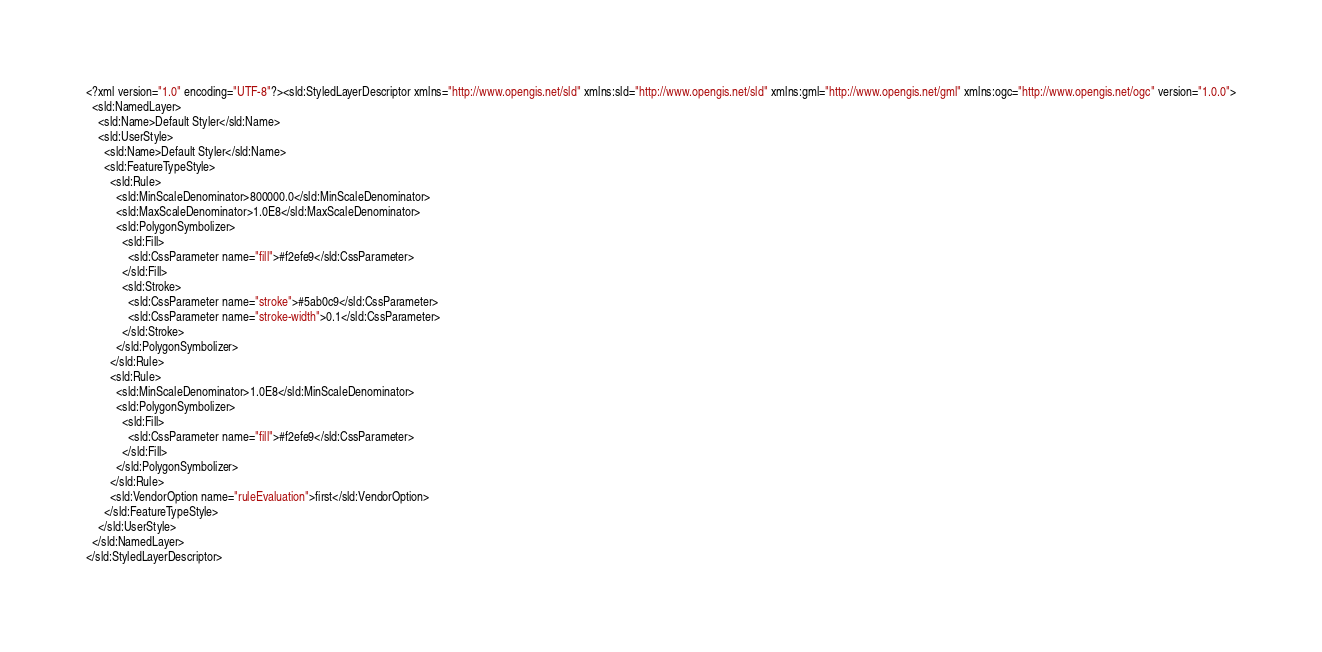<code> <loc_0><loc_0><loc_500><loc_500><_Scheme_><?xml version="1.0" encoding="UTF-8"?><sld:StyledLayerDescriptor xmlns="http://www.opengis.net/sld" xmlns:sld="http://www.opengis.net/sld" xmlns:gml="http://www.opengis.net/gml" xmlns:ogc="http://www.opengis.net/ogc" version="1.0.0">
  <sld:NamedLayer>
    <sld:Name>Default Styler</sld:Name>
    <sld:UserStyle>
      <sld:Name>Default Styler</sld:Name>
      <sld:FeatureTypeStyle>
        <sld:Rule>
          <sld:MinScaleDenominator>800000.0</sld:MinScaleDenominator>
          <sld:MaxScaleDenominator>1.0E8</sld:MaxScaleDenominator>
          <sld:PolygonSymbolizer>
            <sld:Fill>
              <sld:CssParameter name="fill">#f2efe9</sld:CssParameter>
            </sld:Fill>
            <sld:Stroke>
              <sld:CssParameter name="stroke">#5ab0c9</sld:CssParameter>
              <sld:CssParameter name="stroke-width">0.1</sld:CssParameter>
            </sld:Stroke>
          </sld:PolygonSymbolizer>
        </sld:Rule>
        <sld:Rule>
          <sld:MinScaleDenominator>1.0E8</sld:MinScaleDenominator>
          <sld:PolygonSymbolizer>
            <sld:Fill>
              <sld:CssParameter name="fill">#f2efe9</sld:CssParameter>
            </sld:Fill>
          </sld:PolygonSymbolizer>
        </sld:Rule>
        <sld:VendorOption name="ruleEvaluation">first</sld:VendorOption>
      </sld:FeatureTypeStyle>
    </sld:UserStyle>
  </sld:NamedLayer>
</sld:StyledLayerDescriptor>

</code> 